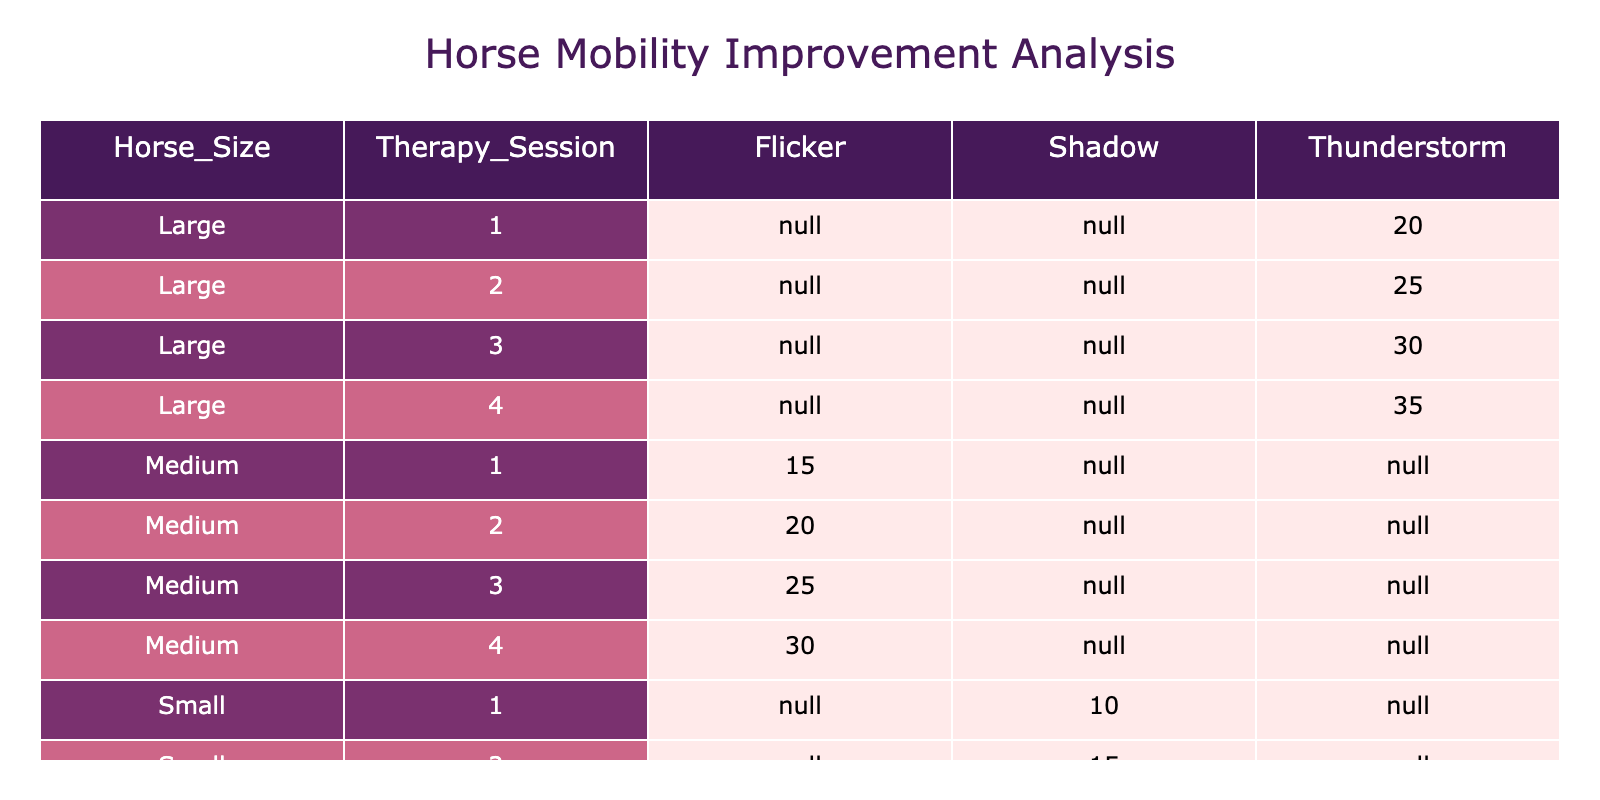What is the improvement score for Flicker in the first therapy session? The table shows the improvement scores under the column corresponding to Flicker and the first therapy session. The score listed there is 15.
Answer: 15 What is the total improvement score for Thunderstorm across all therapy sessions? Summing the improvement scores across the therapy sessions for Thunderstorm: (20 + 25 + 30 + 35) = 110.
Answer: 110 Did Shadow have a higher improvement score in the second or third therapy session? By comparing the improvement scores for Shadow in the second therapy session (15) and the third therapy session (20), it is clear that the score in the third therapy session is higher.
Answer: Yes What is the average improvement score for Medium-sized horses across all therapy sessions? The improvement scores for Medium-sized horses are: 15 (session 1), 20 (session 2), 25 (session 3), 30 (session 4). Summing these gives 15 + 20 + 25 + 30 = 90, and there are 4 scores, so the average is 90/4 = 22.5.
Answer: 22.5 Which horse showed the most improvement from the first to the fourth therapy session? To determine this, we must look at the specific scores: Thunderstorm improved from 20 to 35 (an increase of 15), Flicker from 15 to 30 (an increase of 15), and Shadow from 10 to 25 (an increase of 15). All three horses had equal improvement of 15.
Answer: Equal improvement of 15 across all three horses 